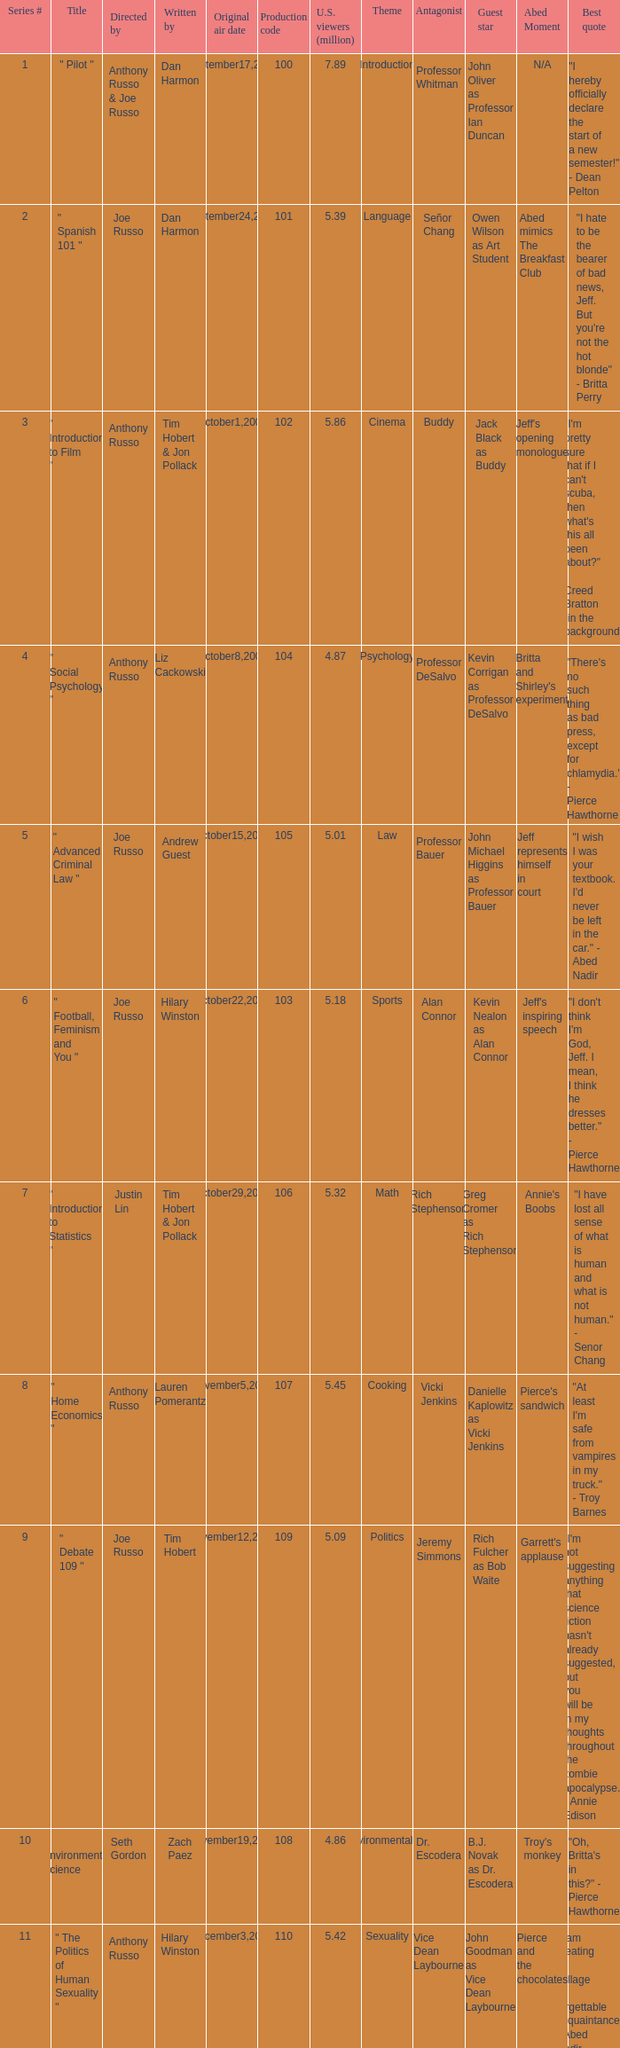How many episodes had a production code 120? 1.0. 